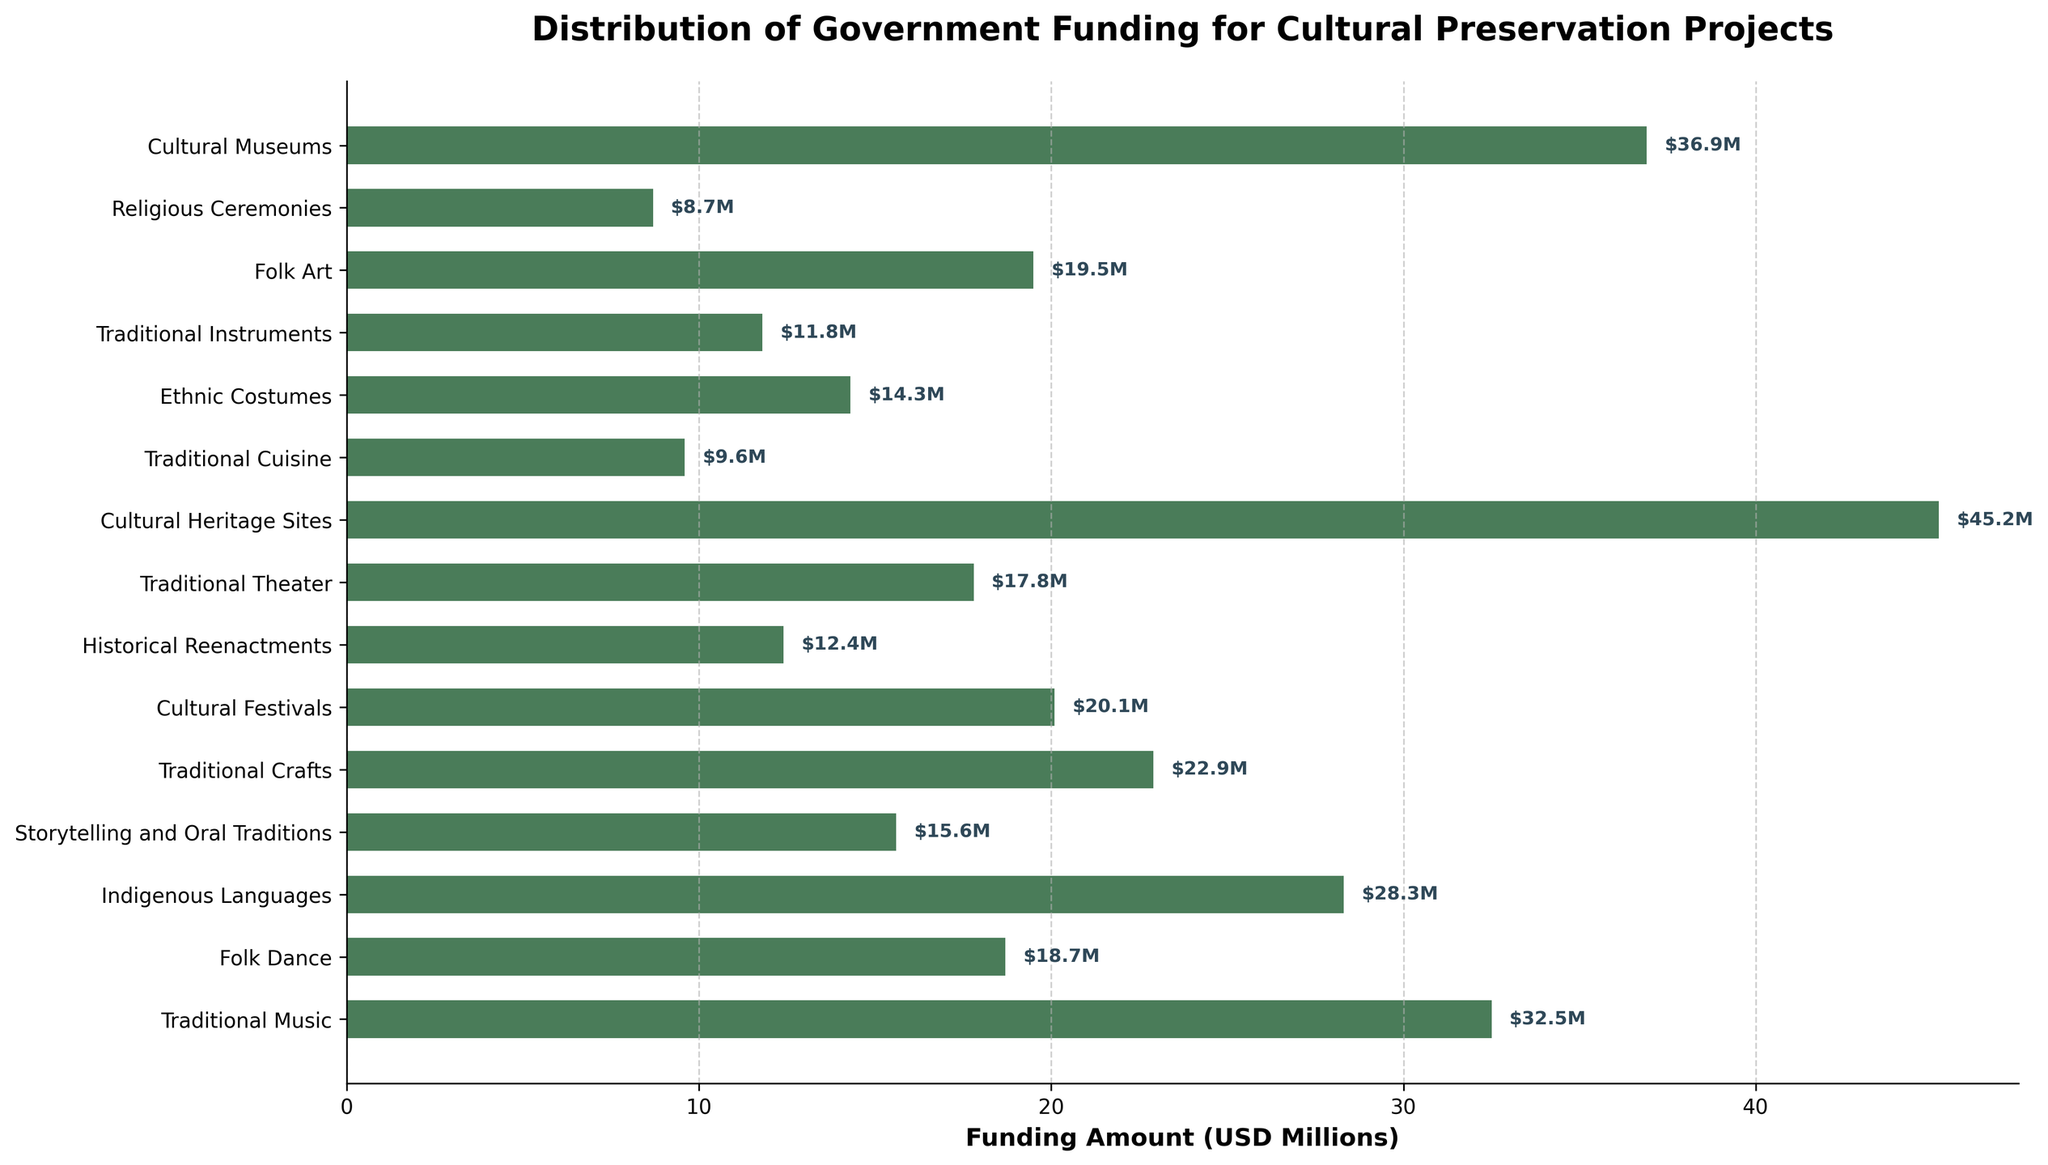Which art form received the highest amount of government funding? Look for the bar with the longest length, which represents the highest funding. In this case, the bar representing "Cultural Heritage Sites" is the longest.
Answer: Cultural Heritage Sites How much more funding did Traditional Music receive compared to Folk Dance? Find and subtract the funding amounts: Traditional Music ($32.5M) and Folk Dance ($18.7M). The difference is $32.5M - $18.7M.
Answer: $13.8M Which art form received the least amount of government funding? Look for the bar with the shortest length, which represents the lowest funding. In this case, the bar representing "Religious Ceremonies" is the shortest.
Answer: Religious Ceremonies What is the total funding amount for Folk Dance, Traditional Theater, and Religious Ceremonies combined? Add the funding amounts for Folk Dance ($18.7M), Traditional Theater ($17.8M), and Religious Ceremonies ($8.7M): $18.7M + $17.8M + $8.7M.
Answer: $45.2M Does Storytelling and Oral Traditions receive more funding than Traditional Instruments? Compare the lengths of the bars for Storytelling and Oral Traditions ($15.6M) and Traditional Instruments ($11.8M). $15.6M is greater than $11.8M.
Answer: Yes What is the average funding amount for Traditional Music, Indigenous Languages, and Cultural Museums? Sum the funding amounts and divide by the number of art forms: ($32.5M + $28.3M + $36.9M) / 3.
Answer: $32.57M Which art forms received between $10M and $20M in funding? Identify bars whose lengths fall between $10M to $20M: Folk Dance ($18.7M), Storytelling and Oral Traditions ($15.6M), Traditional Theater ($17.8M), Cultural Festivals ($20.1M), Ethnic Costumes ($14.3M), Folk Art ($19.5M), Traditional Instruments ($11.8M), Historical Reenactments ($12.4M). The $20.1M for Cultural Festivals is slightly above $20M.
Answer: Folk Dance, Storytelling and Oral Traditions, Traditional Theater, Ethnic Costumes, Folk Art, Traditional Instruments, Historical Reenactments What is the combined funding amount for the three art forms with the highest funding? Identify the bars with the highest lengths, sum their funding amounts: Cultural Heritage Sites ($45.2M), Cultural Museums ($36.9M), Traditional Music ($32.5M).
Answer: $114.6M 